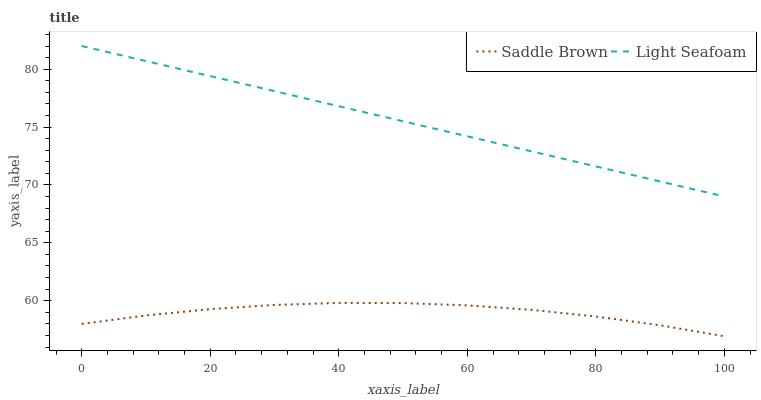Does Saddle Brown have the minimum area under the curve?
Answer yes or no. Yes. Does Light Seafoam have the maximum area under the curve?
Answer yes or no. Yes. Does Saddle Brown have the maximum area under the curve?
Answer yes or no. No. Is Light Seafoam the smoothest?
Answer yes or no. Yes. Is Saddle Brown the roughest?
Answer yes or no. Yes. Is Saddle Brown the smoothest?
Answer yes or no. No. Does Saddle Brown have the lowest value?
Answer yes or no. Yes. Does Light Seafoam have the highest value?
Answer yes or no. Yes. Does Saddle Brown have the highest value?
Answer yes or no. No. Is Saddle Brown less than Light Seafoam?
Answer yes or no. Yes. Is Light Seafoam greater than Saddle Brown?
Answer yes or no. Yes. Does Saddle Brown intersect Light Seafoam?
Answer yes or no. No. 